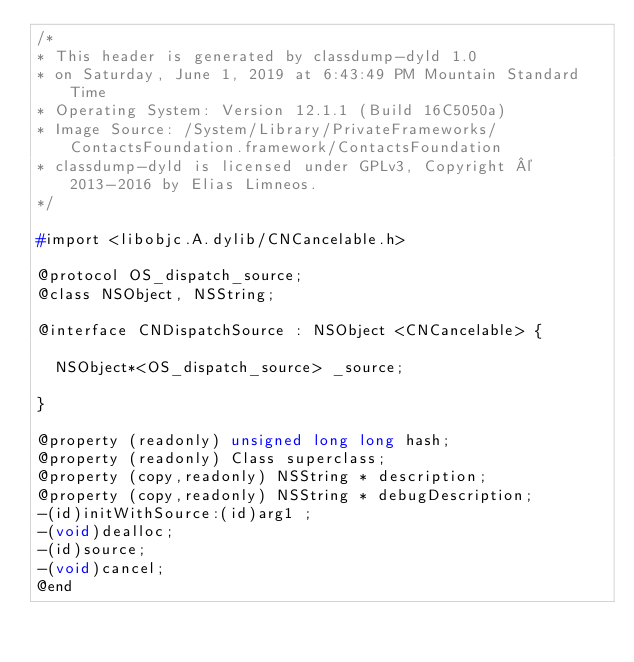<code> <loc_0><loc_0><loc_500><loc_500><_C_>/*
* This header is generated by classdump-dyld 1.0
* on Saturday, June 1, 2019 at 6:43:49 PM Mountain Standard Time
* Operating System: Version 12.1.1 (Build 16C5050a)
* Image Source: /System/Library/PrivateFrameworks/ContactsFoundation.framework/ContactsFoundation
* classdump-dyld is licensed under GPLv3, Copyright © 2013-2016 by Elias Limneos.
*/

#import <libobjc.A.dylib/CNCancelable.h>

@protocol OS_dispatch_source;
@class NSObject, NSString;

@interface CNDispatchSource : NSObject <CNCancelable> {

	NSObject*<OS_dispatch_source> _source;

}

@property (readonly) unsigned long long hash; 
@property (readonly) Class superclass; 
@property (copy,readonly) NSString * description; 
@property (copy,readonly) NSString * debugDescription; 
-(id)initWithSource:(id)arg1 ;
-(void)dealloc;
-(id)source;
-(void)cancel;
@end

</code> 